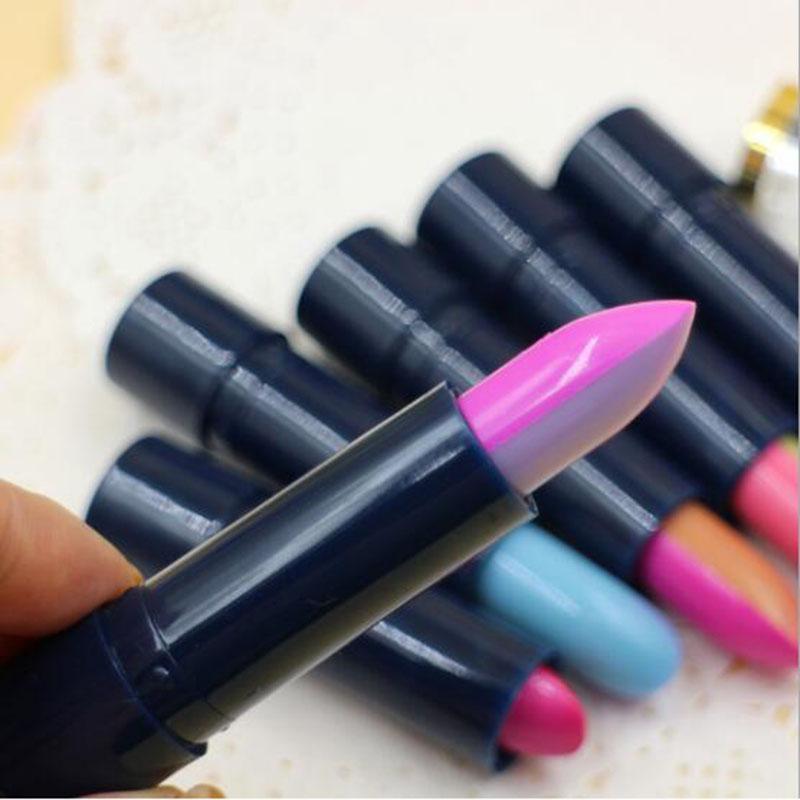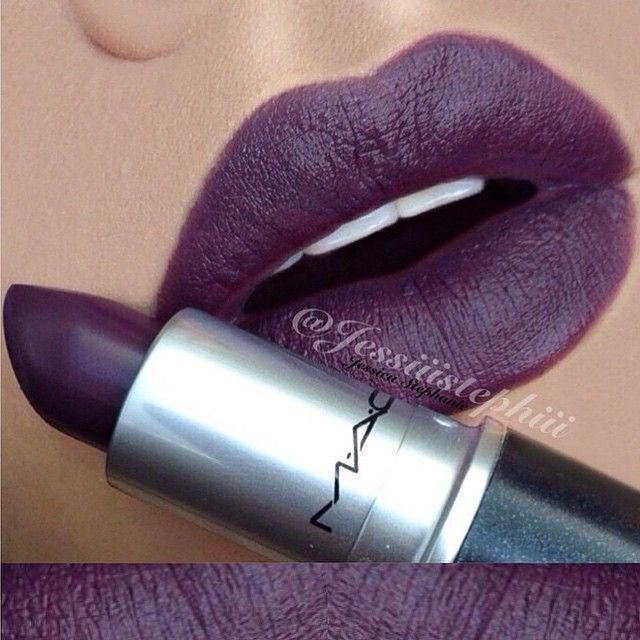The first image is the image on the left, the second image is the image on the right. For the images displayed, is the sentence "An image shows a lipstick by colored lips." factually correct? Answer yes or no. Yes. 